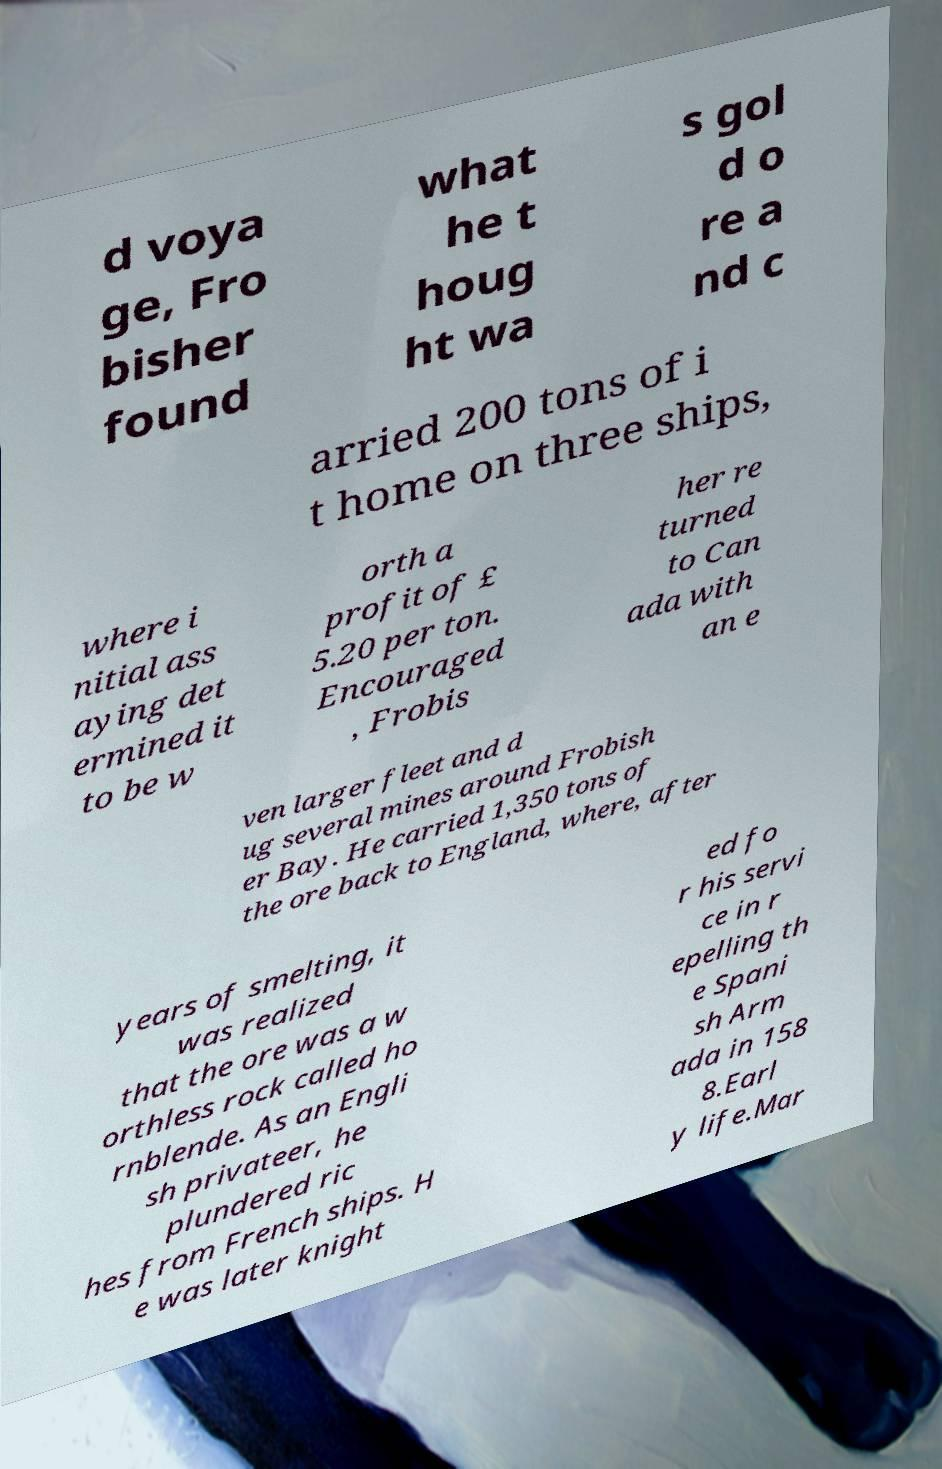What messages or text are displayed in this image? I need them in a readable, typed format. d voya ge, Fro bisher found what he t houg ht wa s gol d o re a nd c arried 200 tons of i t home on three ships, where i nitial ass aying det ermined it to be w orth a profit of £ 5.20 per ton. Encouraged , Frobis her re turned to Can ada with an e ven larger fleet and d ug several mines around Frobish er Bay. He carried 1,350 tons of the ore back to England, where, after years of smelting, it was realized that the ore was a w orthless rock called ho rnblende. As an Engli sh privateer, he plundered ric hes from French ships. H e was later knight ed fo r his servi ce in r epelling th e Spani sh Arm ada in 158 8.Earl y life.Mar 